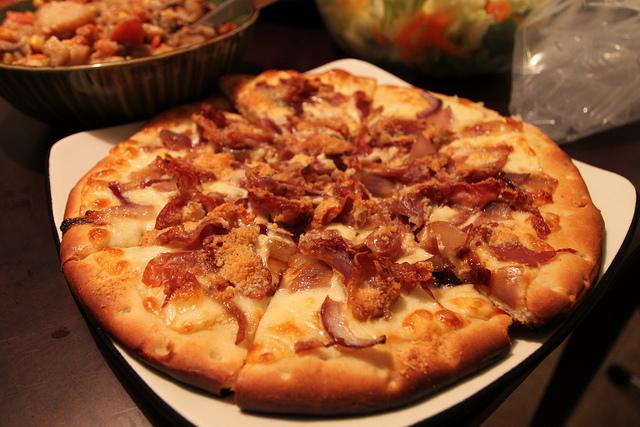What toppings are on the pizza?
Quick response, please. Bacon. Where is the pizza from?
Answer briefly. Restaurant. What is the food on?
Concise answer only. Plate. How many slices are there?
Keep it brief. 6. 